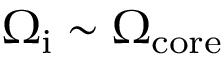Convert formula to latex. <formula><loc_0><loc_0><loc_500><loc_500>\Omega _ { i } \sim \Omega _ { c o r e }</formula> 